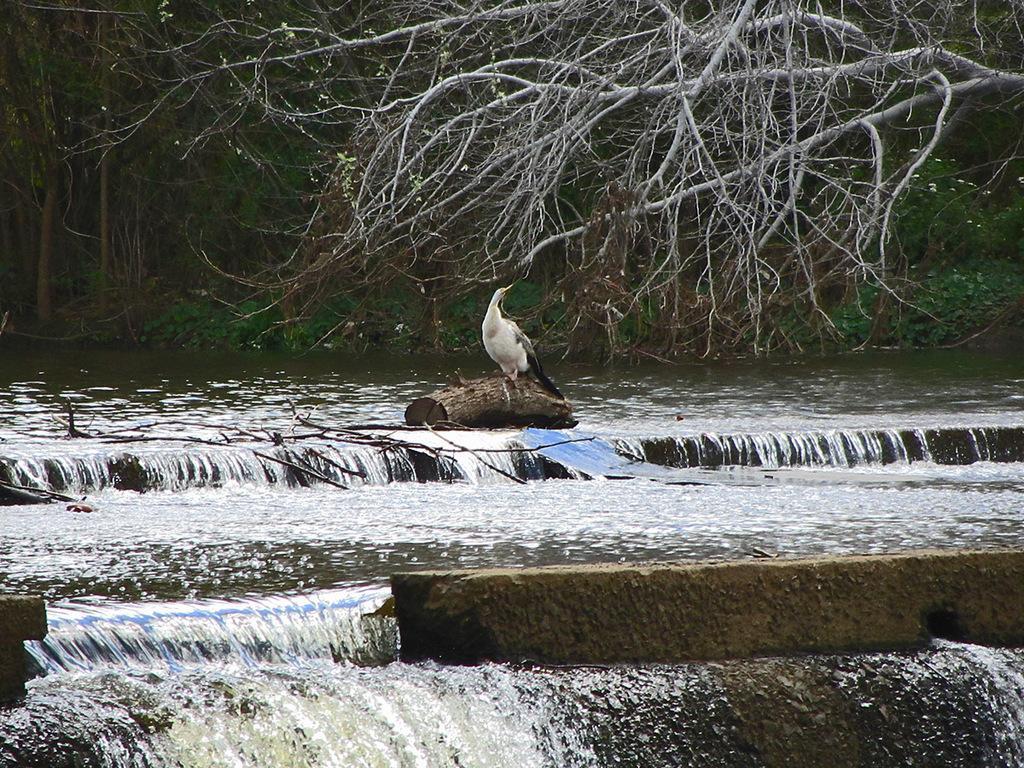Can you describe this image briefly? In this image, there is water, at the middle there is a bird sitting on a tree trunk, there are some trees. 